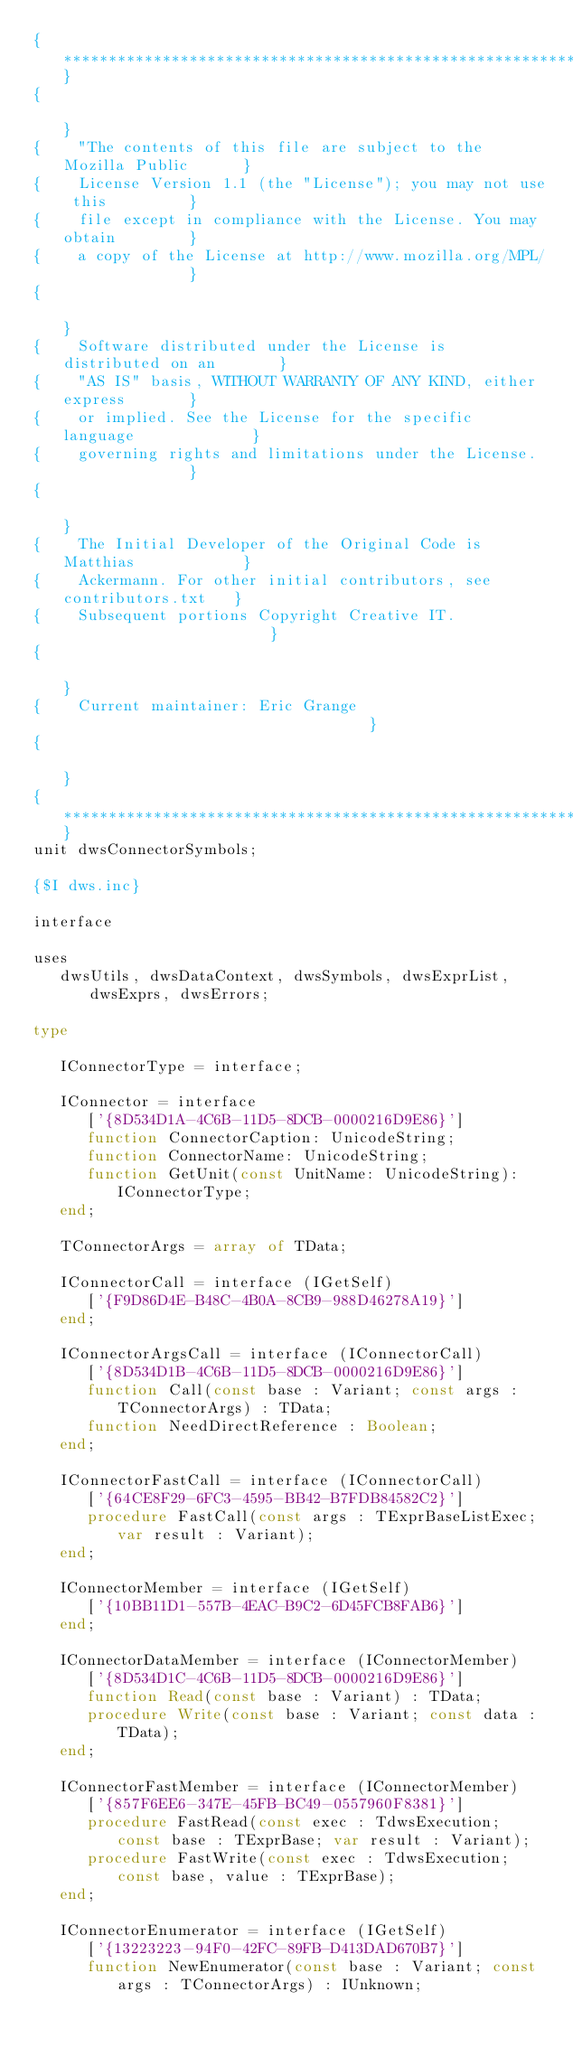Convert code to text. <code><loc_0><loc_0><loc_500><loc_500><_Pascal_>{**********************************************************************}
{                                                                      }
{    "The contents of this file are subject to the Mozilla Public      }
{    License Version 1.1 (the "License"); you may not use this         }
{    file except in compliance with the License. You may obtain        }
{    a copy of the License at http://www.mozilla.org/MPL/              }
{                                                                      }
{    Software distributed under the License is distributed on an       }
{    "AS IS" basis, WITHOUT WARRANTY OF ANY KIND, either express       }
{    or implied. See the License for the specific language             }
{    governing rights and limitations under the License.               }
{                                                                      }
{    The Initial Developer of the Original Code is Matthias            }
{    Ackermann. For other initial contributors, see contributors.txt   }
{    Subsequent portions Copyright Creative IT.                        }
{                                                                      }
{    Current maintainer: Eric Grange                                   }
{                                                                      }
{**********************************************************************}
unit dwsConnectorSymbols;

{$I dws.inc}

interface

uses
   dwsUtils, dwsDataContext, dwsSymbols, dwsExprList, dwsExprs, dwsErrors;

type

   IConnectorType = interface;

   IConnector = interface
      ['{8D534D1A-4C6B-11D5-8DCB-0000216D9E86}']
      function ConnectorCaption: UnicodeString;
      function ConnectorName: UnicodeString;
      function GetUnit(const UnitName: UnicodeString): IConnectorType;
   end;

   TConnectorArgs = array of TData;

   IConnectorCall = interface (IGetSelf)
      ['{F9D86D4E-B48C-4B0A-8CB9-988D46278A19}']
   end;

   IConnectorArgsCall = interface (IConnectorCall)
      ['{8D534D1B-4C6B-11D5-8DCB-0000216D9E86}']
      function Call(const base : Variant; const args : TConnectorArgs) : TData;
      function NeedDirectReference : Boolean;
   end;

   IConnectorFastCall = interface (IConnectorCall)
      ['{64CE8F29-6FC3-4595-BB42-B7FDB84582C2}']
      procedure FastCall(const args : TExprBaseListExec; var result : Variant);
   end;

   IConnectorMember = interface (IGetSelf)
      ['{10BB11D1-557B-4EAC-B9C2-6D45FCB8FAB6}']
   end;

   IConnectorDataMember = interface (IConnectorMember)
      ['{8D534D1C-4C6B-11D5-8DCB-0000216D9E86}']
      function Read(const base : Variant) : TData;
      procedure Write(const base : Variant; const data : TData);
   end;

   IConnectorFastMember = interface (IConnectorMember)
      ['{857F6EE6-347E-45FB-BC49-0557960F8381}']
      procedure FastRead(const exec : TdwsExecution; const base : TExprBase; var result : Variant);
      procedure FastWrite(const exec : TdwsExecution; const base, value : TExprBase);
   end;

   IConnectorEnumerator = interface (IGetSelf)
      ['{13223223-94F0-42FC-89FB-D413DAD670B7}']
      function NewEnumerator(const base : Variant; const args : TConnectorArgs) : IUnknown;</code> 